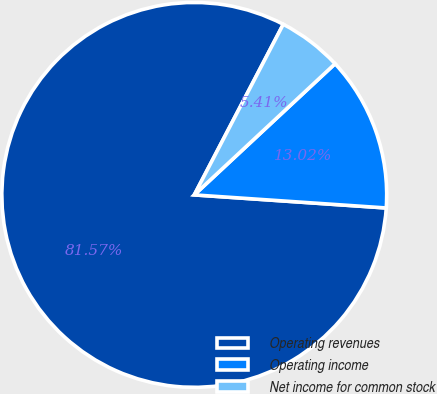Convert chart to OTSL. <chart><loc_0><loc_0><loc_500><loc_500><pie_chart><fcel>Operating revenues<fcel>Operating income<fcel>Net income for common stock<nl><fcel>81.57%<fcel>13.02%<fcel>5.41%<nl></chart> 